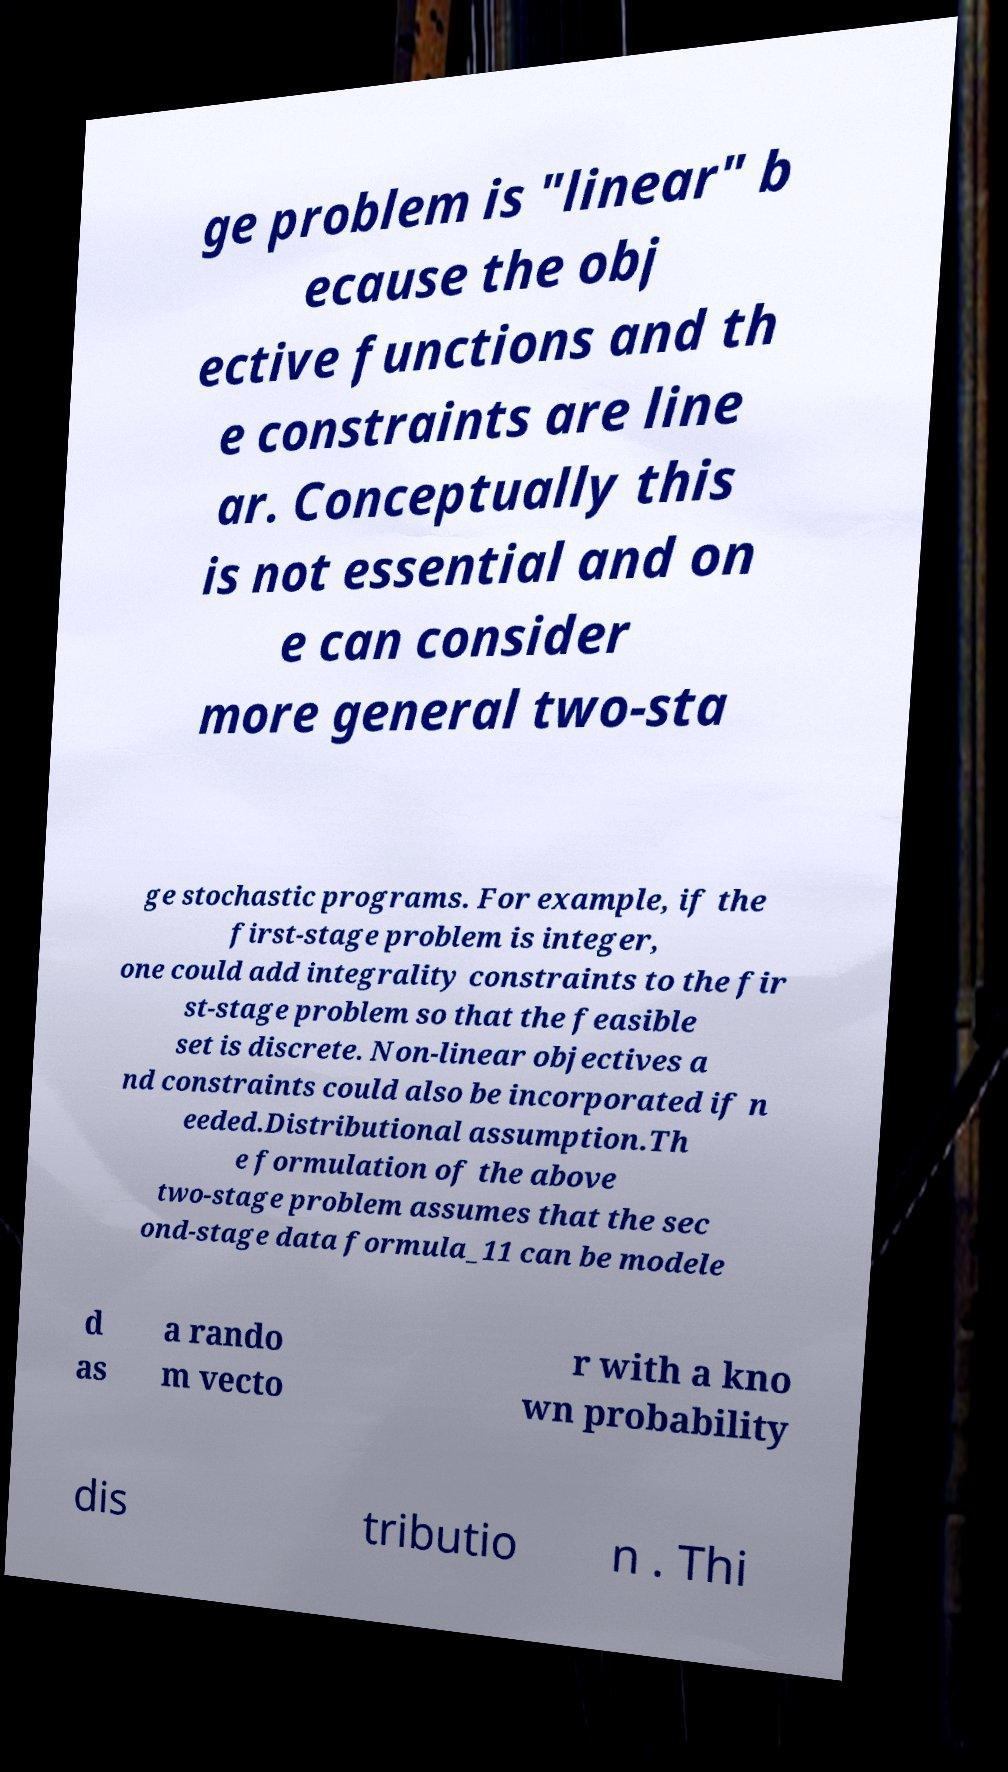I need the written content from this picture converted into text. Can you do that? ge problem is "linear" b ecause the obj ective functions and th e constraints are line ar. Conceptually this is not essential and on e can consider more general two-sta ge stochastic programs. For example, if the first-stage problem is integer, one could add integrality constraints to the fir st-stage problem so that the feasible set is discrete. Non-linear objectives a nd constraints could also be incorporated if n eeded.Distributional assumption.Th e formulation of the above two-stage problem assumes that the sec ond-stage data formula_11 can be modele d as a rando m vecto r with a kno wn probability dis tributio n . Thi 